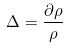<formula> <loc_0><loc_0><loc_500><loc_500>\Delta = \frac { \partial \rho } { \rho }</formula> 